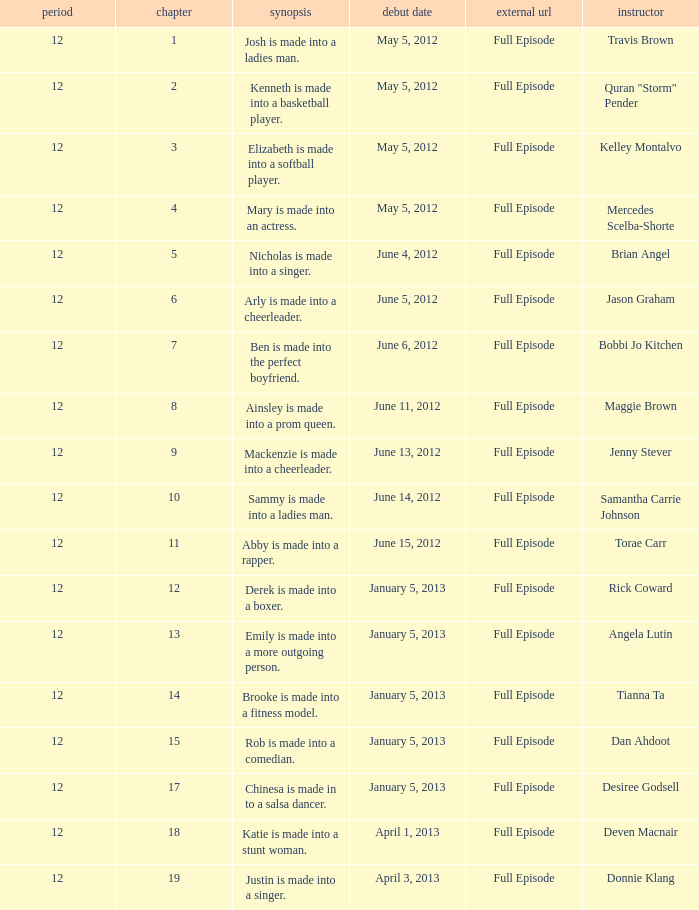Name the episode for travis brown 1.0. 